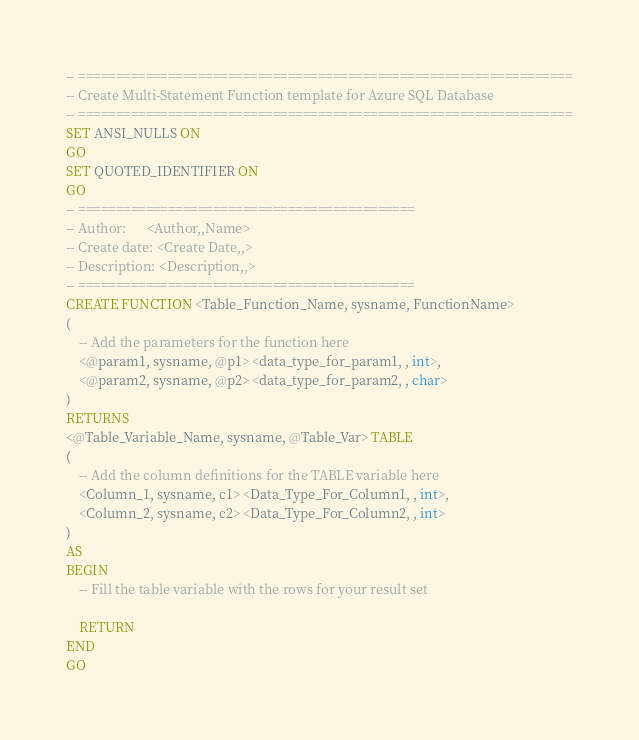Convert code to text. <code><loc_0><loc_0><loc_500><loc_500><_SQL_>-- ==================================================================
-- Create Multi-Statement Function template for Azure SQL Database
-- ==================================================================
SET ANSI_NULLS ON
GO
SET QUOTED_IDENTIFIER ON
GO
-- =============================================
-- Author:		<Author,,Name>
-- Create date: <Create Date,,>
-- Description:	<Description,,>
-- =============================================
CREATE FUNCTION <Table_Function_Name, sysname, FunctionName> 
(
	-- Add the parameters for the function here
	<@param1, sysname, @p1> <data_type_for_param1, , int>, 
	<@param2, sysname, @p2> <data_type_for_param2, , char>
)
RETURNS 
<@Table_Variable_Name, sysname, @Table_Var> TABLE 
(
	-- Add the column definitions for the TABLE variable here
	<Column_1, sysname, c1> <Data_Type_For_Column1, , int>, 
	<Column_2, sysname, c2> <Data_Type_For_Column2, , int>
)
AS
BEGIN
	-- Fill the table variable with the rows for your result set
	
	RETURN 
END
GO
</code> 